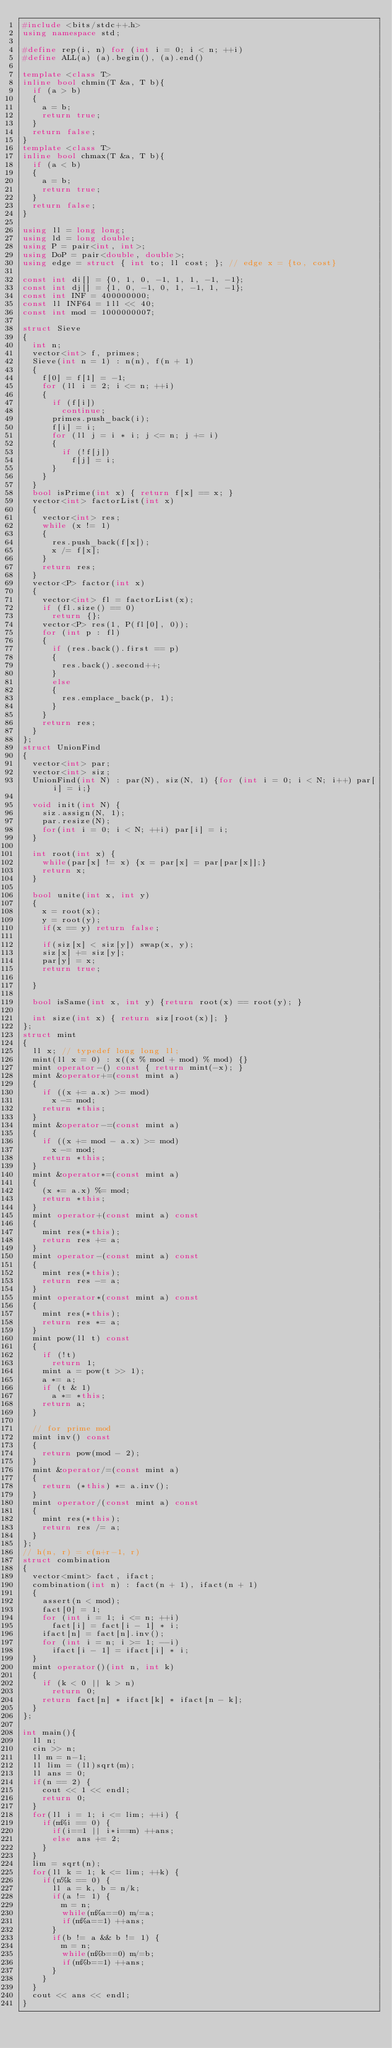Convert code to text. <code><loc_0><loc_0><loc_500><loc_500><_C++_>#include <bits/stdc++.h>
using namespace std;

#define rep(i, n) for (int i = 0; i < n; ++i)
#define ALL(a) (a).begin(), (a).end()

template <class T>
inline bool chmin(T &a, T b){
  if (a > b)
  {
    a = b;
    return true;
  }
  return false;
}
template <class T>
inline bool chmax(T &a, T b){
  if (a < b)
  {
    a = b;
    return true;
  }
  return false;
}

using ll = long long;
using ld = long double;
using P = pair<int, int>;
using DoP = pair<double, double>;
using edge = struct { int to; ll cost; }; // edge x = {to, cost}

const int di[] = {0, 1, 0, -1, 1, 1, -1, -1};
const int dj[] = {1, 0, -1, 0, 1, -1, 1, -1};
const int INF = 400000000;
const ll INF64 = 1ll << 40;
const int mod = 1000000007;

struct Sieve
{
  int n;
  vector<int> f, primes;
  Sieve(int n = 1) : n(n), f(n + 1)
  {
    f[0] = f[1] = -1;
    for (ll i = 2; i <= n; ++i)
    {
      if (f[i])
        continue;
      primes.push_back(i);
      f[i] = i;
      for (ll j = i * i; j <= n; j += i)
      {
        if (!f[j])
          f[j] = i;
      }
    }
  }
  bool isPrime(int x) { return f[x] == x; }
  vector<int> factorList(int x)
  {
    vector<int> res;
    while (x != 1)
    {
      res.push_back(f[x]);
      x /= f[x];
    }
    return res;
  }
  vector<P> factor(int x)
  {
    vector<int> fl = factorList(x);
    if (fl.size() == 0)
      return {};
    vector<P> res(1, P(fl[0], 0));
    for (int p : fl)
    {
      if (res.back().first == p)
      {
        res.back().second++;
      }
      else
      {
        res.emplace_back(p, 1);
      }
    }
    return res;
  }
};
struct UnionFind
{
  vector<int> par;
  vector<int> siz;
  UnionFind(int N) : par(N), siz(N, 1) {for (int i = 0; i < N; i++) par[i] = i;}
  
  void init(int N) {
    siz.assign(N, 1);
    par.resize(N);
    for(int i = 0; i < N; ++i) par[i] = i;
  }

  int root(int x) {
    while(par[x] != x) {x = par[x] = par[par[x]];}
    return x;
  }

  bool unite(int x, int y)
  {
    x = root(x);
    y = root(y);
    if(x == y) return false;

    if(siz[x] < siz[y]) swap(x, y);
    siz[x] += siz[y];
    par[y] = x;
    return true;

  }

  bool isSame(int x, int y) {return root(x) == root(y); }

  int size(int x) { return siz[root(x)]; }
};
struct mint
{
  ll x; // typedef long long ll;
  mint(ll x = 0) : x((x % mod + mod) % mod) {}
  mint operator-() const { return mint(-x); }
  mint &operator+=(const mint a)
  {
    if ((x += a.x) >= mod)
      x -= mod;
    return *this;
  }
  mint &operator-=(const mint a)
  {
    if ((x += mod - a.x) >= mod)
      x -= mod;
    return *this;
  }
  mint &operator*=(const mint a)
  {
    (x *= a.x) %= mod;
    return *this;
  }
  mint operator+(const mint a) const
  {
    mint res(*this);
    return res += a;
  }
  mint operator-(const mint a) const
  {
    mint res(*this);
    return res -= a;
  }
  mint operator*(const mint a) const
  {
    mint res(*this);
    return res *= a;
  }
  mint pow(ll t) const
  {
    if (!t)
      return 1;
    mint a = pow(t >> 1);
    a *= a;
    if (t & 1)
      a *= *this;
    return a;
  }

  // for prime mod
  mint inv() const
  {
    return pow(mod - 2);
  }
  mint &operator/=(const mint a)
  {
    return (*this) *= a.inv();
  }
  mint operator/(const mint a) const
  {
    mint res(*this);
    return res /= a;
  }
};
// h(n, r) = c(n+r-1, r)
struct combination
{
  vector<mint> fact, ifact;
  combination(int n) : fact(n + 1), ifact(n + 1)
  {
    assert(n < mod);
    fact[0] = 1;
    for (int i = 1; i <= n; ++i)
      fact[i] = fact[i - 1] * i;
    ifact[n] = fact[n].inv();
    for (int i = n; i >= 1; --i)
      ifact[i - 1] = ifact[i] * i;
  }
  mint operator()(int n, int k)
  {
    if (k < 0 || k > n)
      return 0;
    return fact[n] * ifact[k] * ifact[n - k];
  }
};

int main(){
  ll n;
  cin >> n;
  ll m = n-1;
  ll lim = (ll)sqrt(m);
  ll ans = 0;
  if(n == 2) {
    cout << 1 << endl;
    return 0;
  }
  for(ll i = 1; i <= lim; ++i) {
    if(m%i == 0) {
      if(i==1 || i*i==m) ++ans;
      else ans += 2;
    }
  }
  lim = sqrt(n);
  for(ll k = 1; k <= lim; ++k) {
    if(n%k == 0) {
      ll a = k, b = n/k;
      if(a != 1) {
        m = n;
        while(m%a==0) m/=a;
        if(m%a==1) ++ans;
      }
      if(b != a && b != 1) {
        m = n;
        while(m%b==0) m/=b;
        if(m%b==1) ++ans;
      }
    }
  }
  cout << ans << endl;
}</code> 